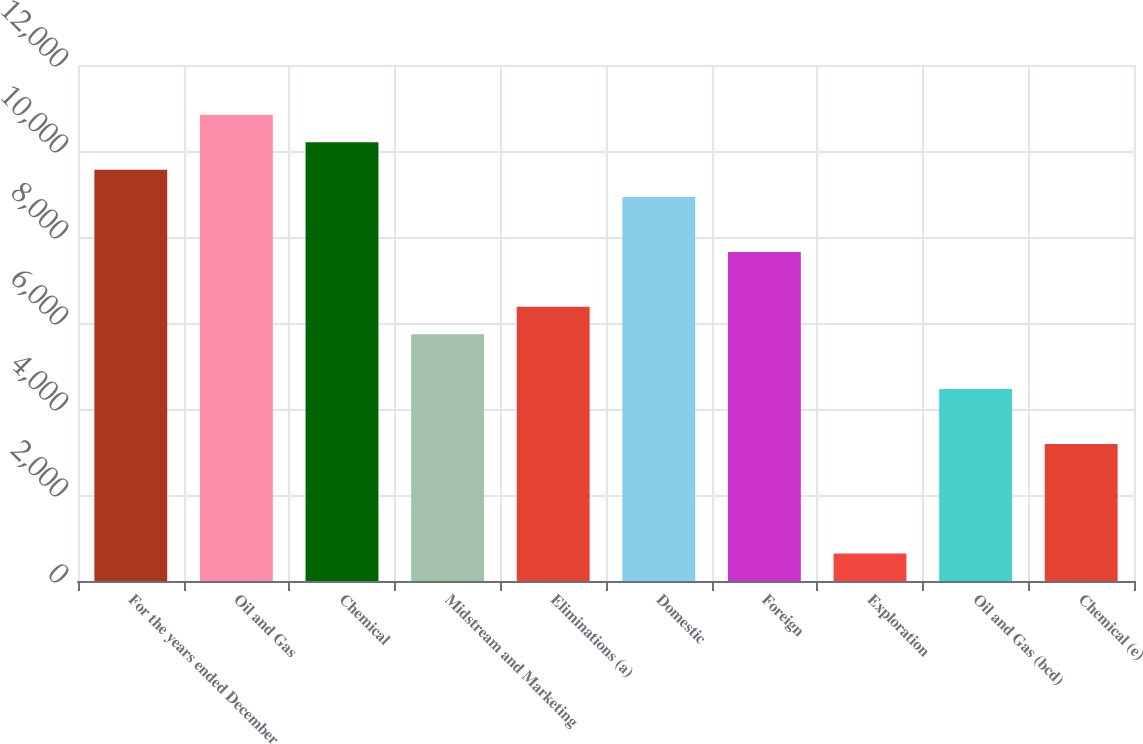Convert chart to OTSL. <chart><loc_0><loc_0><loc_500><loc_500><bar_chart><fcel>For the years ended December<fcel>Oil and Gas<fcel>Chemical<fcel>Midstream and Marketing<fcel>Eliminations (a)<fcel>Domestic<fcel>Foreign<fcel>Exploration<fcel>Oil and Gas (bcd)<fcel>Chemical (e)<nl><fcel>9565.15<fcel>10840.4<fcel>10202.8<fcel>5739.4<fcel>6377.02<fcel>8927.52<fcel>7652.27<fcel>638.38<fcel>4464.14<fcel>3188.89<nl></chart> 